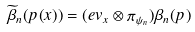Convert formula to latex. <formula><loc_0><loc_0><loc_500><loc_500>\widetilde { \beta } _ { n } ( p ( x ) ) = ( e v _ { x } \otimes \pi _ { \psi _ { n } } ) \beta _ { n } ( p )</formula> 